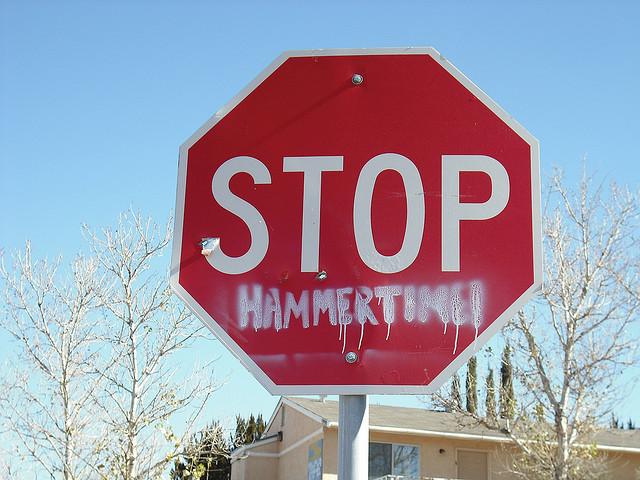What color is the sign writing?
Give a very brief answer. White. What does the red stop sign read under stop?
Be succinct. Hammer time. Are all the trees green?
Short answer required. No. What signal tells your vehicle to no longer be moving for a period of time?
Concise answer only. Stop sign. 